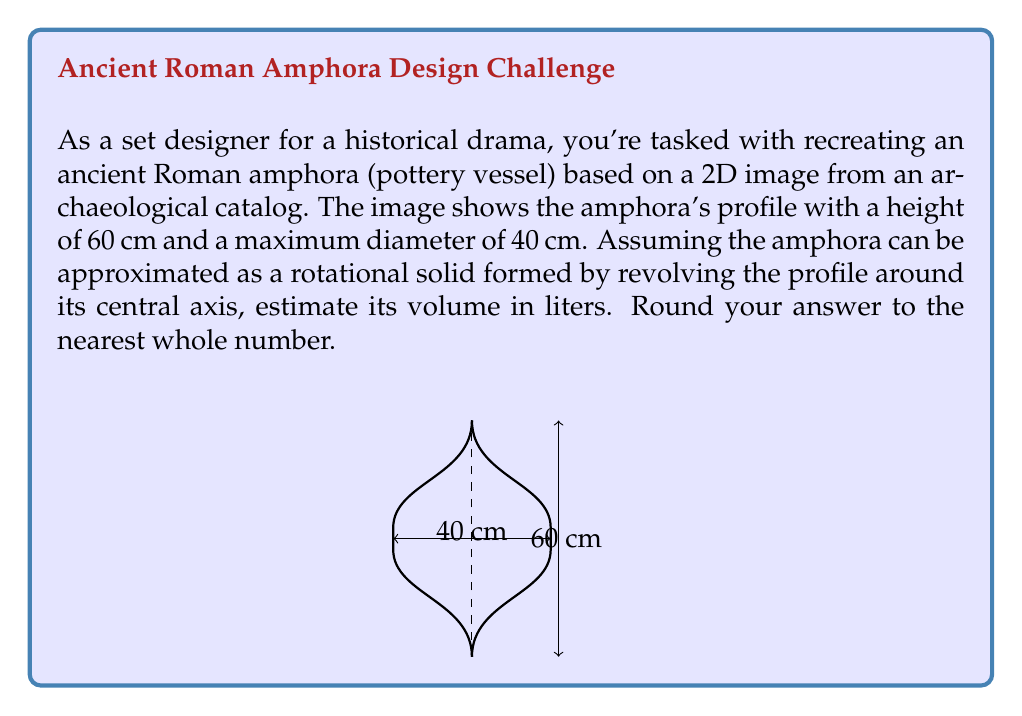Can you solve this math problem? To estimate the volume of the amphora, we can use the method of cylindrical shells:

1) The volume of a solid of revolution is given by the formula:

   $$V = 2\pi \int_0^h r(y) \cdot y \, dy$$

   where $h$ is the height and $r(y)$ is the radius as a function of height.

2) From the image, we can approximate the profile of the amphora as a parabola. The equation of a parabola that passes through (0,0), (20,30), and (0,60) is:

   $$r(y) = -\frac{1}{90}y^2 + \frac{2}{3}y$$

3) Substituting this into our volume formula:

   $$V = 2\pi \int_0^{60} (-\frac{1}{90}y^2 + \frac{2}{3}y) \cdot y \, dy$$

4) Evaluating the integral:

   $$V = 2\pi [\frac{-1}{360}y^4 + \frac{1}{6}y^3]_0^{60}$$
   $$V = 2\pi (\frac{-1}{360}(60^4) + \frac{1}{6}(60^3))$$
   $$V = 2\pi (24000) = 150796.4 \text{ cm}^3$$

5) Converting to liters (1 liter = 1000 cm³):

   $$V = 150796.4 / 1000 = 150.8 \text{ liters}$$

6) Rounding to the nearest whole number:

   $$V \approx 151 \text{ liters}$$
Answer: 151 liters 